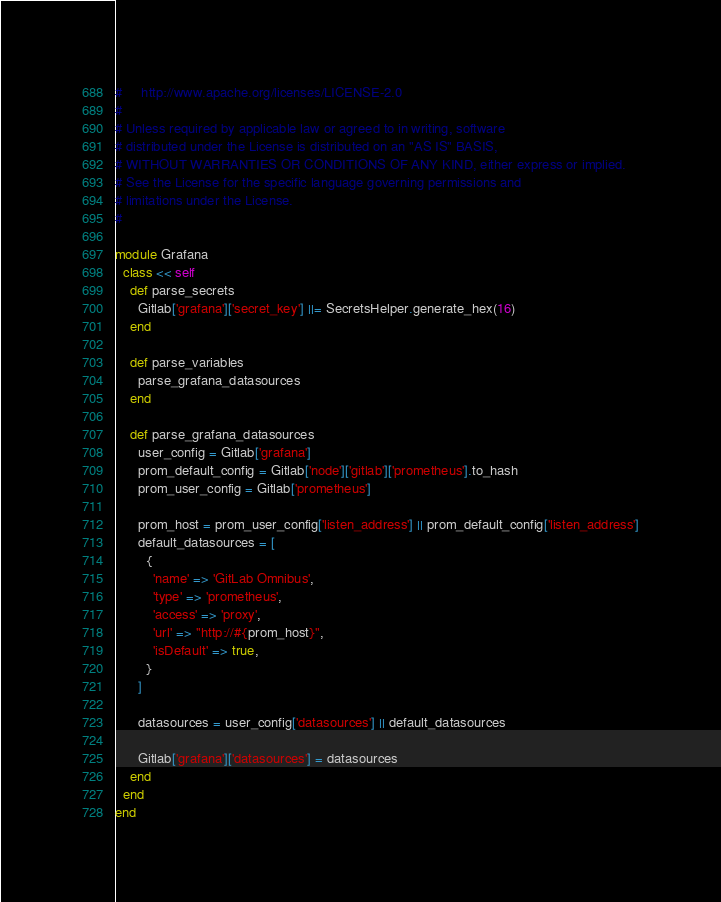<code> <loc_0><loc_0><loc_500><loc_500><_Ruby_>#     http://www.apache.org/licenses/LICENSE-2.0
#
# Unless required by applicable law or agreed to in writing, software
# distributed under the License is distributed on an "AS IS" BASIS,
# WITHOUT WARRANTIES OR CONDITIONS OF ANY KIND, either express or implied.
# See the License for the specific language governing permissions and
# limitations under the License.
#

module Grafana
  class << self
    def parse_secrets
      Gitlab['grafana']['secret_key'] ||= SecretsHelper.generate_hex(16)
    end

    def parse_variables
      parse_grafana_datasources
    end

    def parse_grafana_datasources
      user_config = Gitlab['grafana']
      prom_default_config = Gitlab['node']['gitlab']['prometheus'].to_hash
      prom_user_config = Gitlab['prometheus']

      prom_host = prom_user_config['listen_address'] || prom_default_config['listen_address']
      default_datasources = [
        {
          'name' => 'GitLab Omnibus',
          'type' => 'prometheus',
          'access' => 'proxy',
          'url' => "http://#{prom_host}",
          'isDefault' => true,
        }
      ]

      datasources = user_config['datasources'] || default_datasources

      Gitlab['grafana']['datasources'] = datasources
    end
  end
end
</code> 